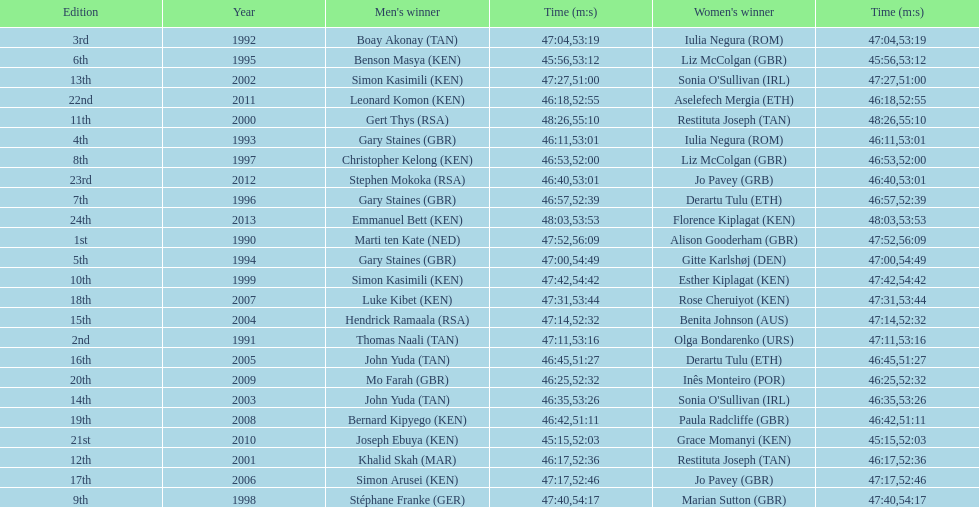Who is the male winner listed before gert thys? Simon Kasimili. 